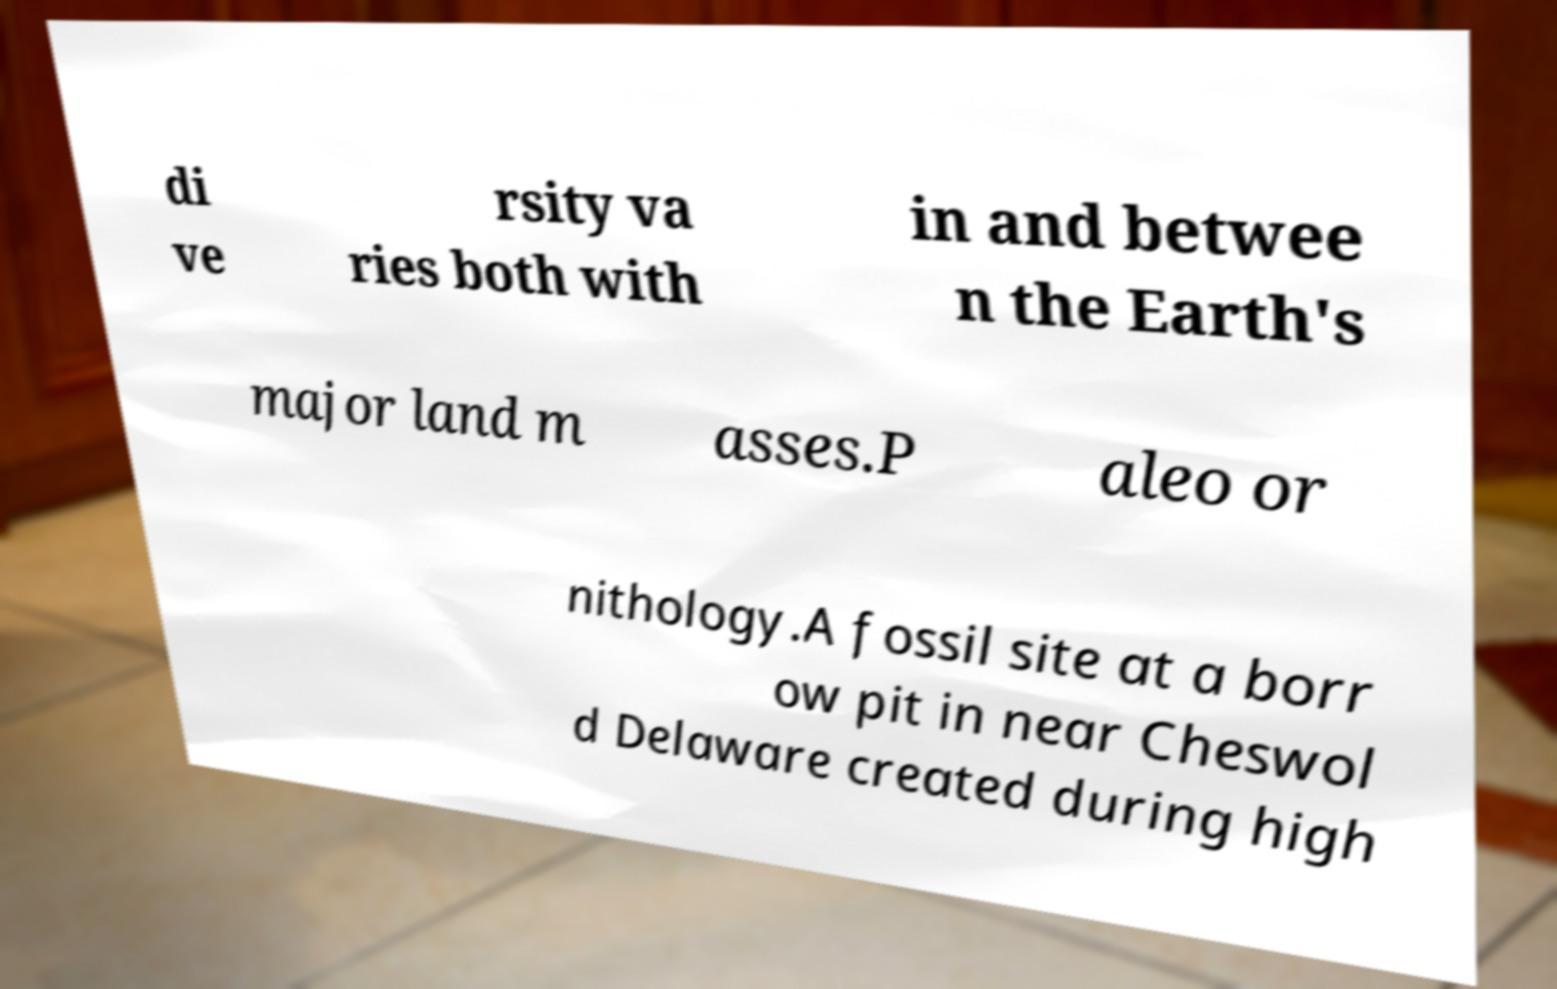Can you read and provide the text displayed in the image?This photo seems to have some interesting text. Can you extract and type it out for me? di ve rsity va ries both with in and betwee n the Earth's major land m asses.P aleo or nithology.A fossil site at a borr ow pit in near Cheswol d Delaware created during high 